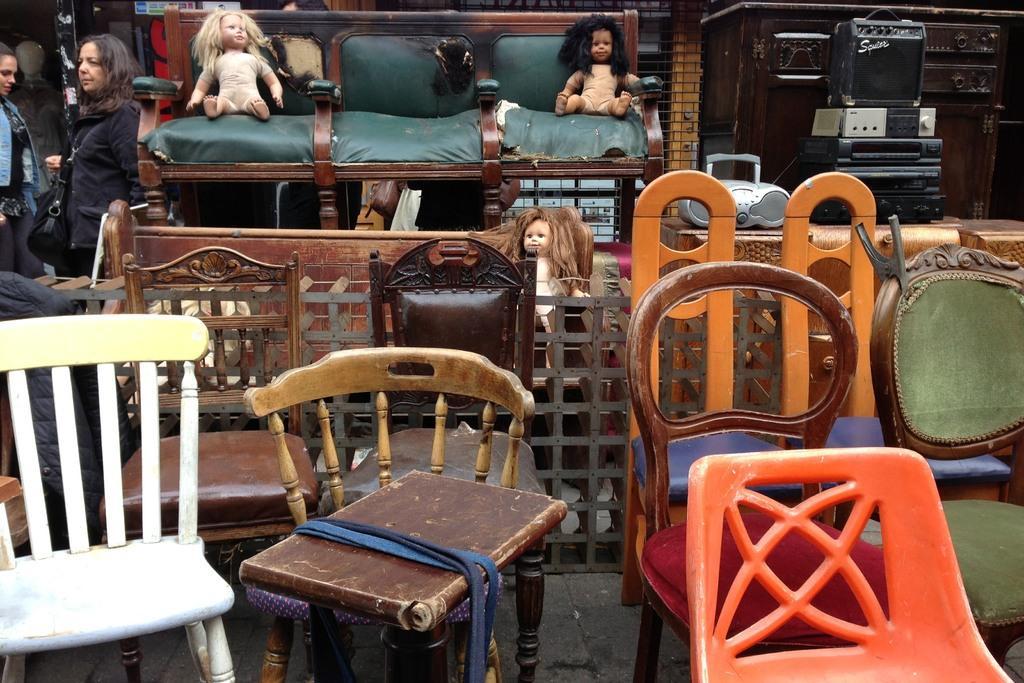Could you give a brief overview of what you see in this image? Some old furniture is kept for sale on road. There are some chairs,sofa,dolls and music system with speakers among them. People are passing by them. 